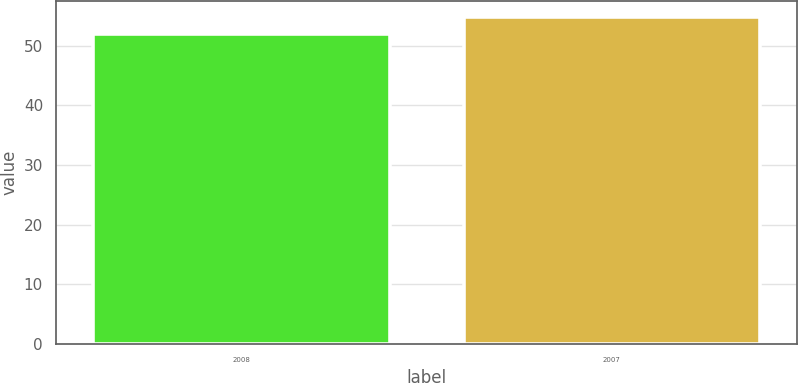Convert chart. <chart><loc_0><loc_0><loc_500><loc_500><bar_chart><fcel>2008<fcel>2007<nl><fcel>52<fcel>54.83<nl></chart> 